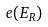<formula> <loc_0><loc_0><loc_500><loc_500>e ( E _ { R } )</formula> 